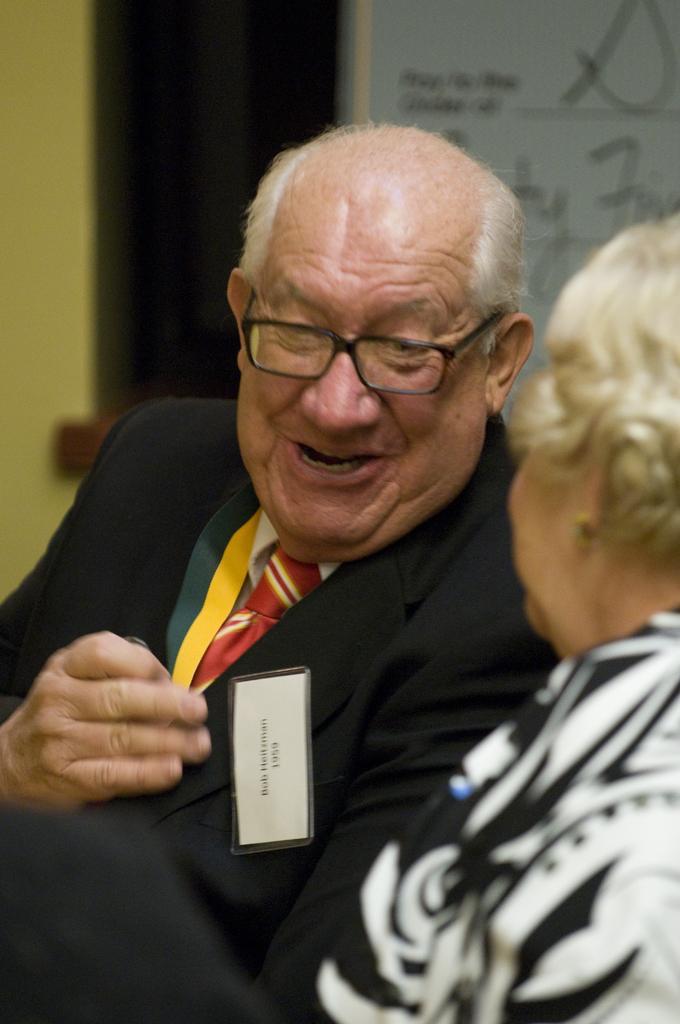Could you give a brief overview of what you see in this image? On the right we can see a woman. In the middle of the picture there is a person in black suit, he is talking. The background is blurred. 